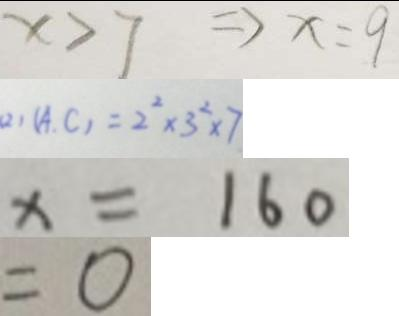Convert formula to latex. <formula><loc_0><loc_0><loc_500><loc_500>x > 7 \Rightarrow x = 9 
 ( 2 ) ( A , C ) = 2 ^ { 2 } \times 3 ^ { 2 } \times 7 
 x = 1 6 0 
 = 0</formula> 